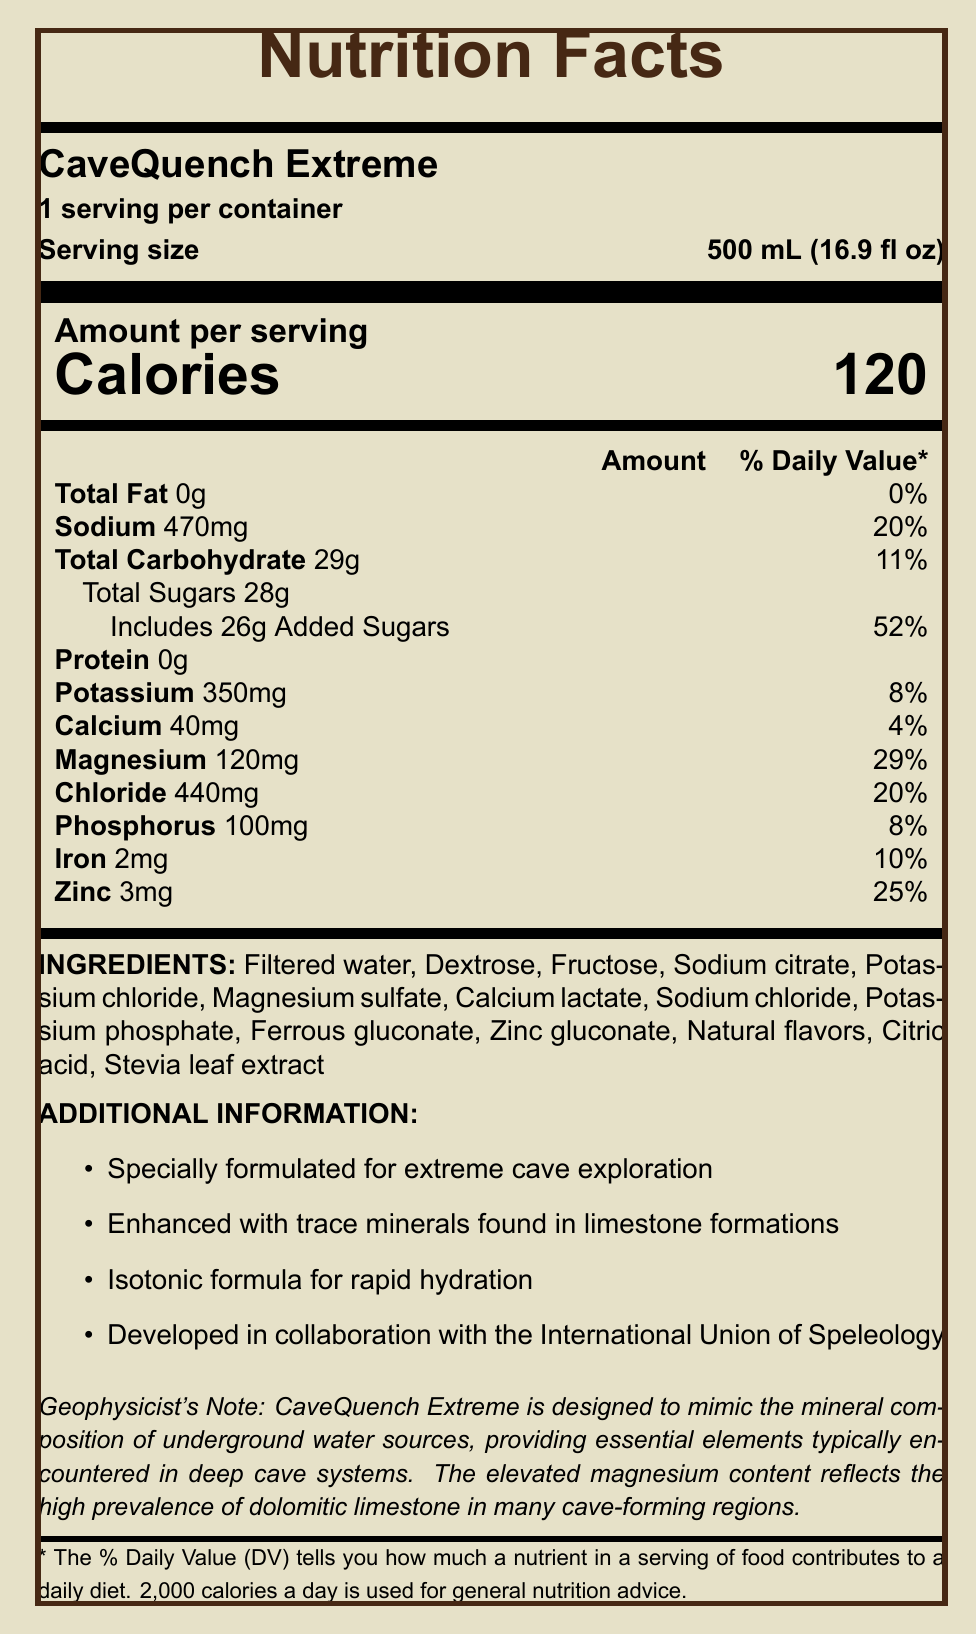what is the product name? The product name is clearly listed at the top of the document.
Answer: CaveQuench Extreme what is the serving size? The serving size is specified right below the product name.
Answer: 500 mL (16.9 fl oz) how many calories are in one serving? The document states "Calories 120" under the "Amount per serving" section.
Answer: 120 calories what is the percentage of daily value for sodium in one serving? The document lists sodium content as 470mg, which is 20% of the daily value.
Answer: 20% how much magnesium is in one serving? The document lists the magnesium content as 120mg.
Answer: 120mg based on the document, what kind of contexts is CaveQuench Extreme specially formulated for? The "Additional Information" section specifies that the beverage is "specially formulated for extreme cave exploration."
Answer: extreme cave exploration what ingredients are used in CaveQuench Extreme? The ingredients are listed under the "INGREDIENTS" section in the document.
Answer: Filtered water, Dextrose, Fructose, Sodium citrate, Potassium chloride, Magnesium sulfate, Calcium lactate, Sodium chloride, Potassium phosphate, Ferrous gluconate, Zinc gluconate, Natural flavors, Citric acid, Stevia leaf extract how many grams of total carbohydrates are in one serving? The document lists the total carbohydrate content as 29g under the nutritional information.
Answer: 29g what organization collaborated in the development of CaveQuench Extreme? The "Additional Information" section states that the product was "developed in collaboration with the International Union of Speleology."
Answer: International Union of Speleology which of the following is NOT listed as a trace mineral in CaveQuench Extreme? A. Magnesium B. Iron C. Selenium D. Zinc Selenium is not listed in the nutritional information, while Magnesium, Iron, and Zinc are.
Answer: C. Selenium what is the percentage of daily value for added sugars in one serving? A. 26% B. 52% C. 11% D. 29% The document lists "Includes 26g Added Sugars" and mentions this is 52% of the daily value.
Answer: B. 52% is this beverage suitable for someone on a low-sodium diet? The document lists sodium content as 470mg, which is 20% of the daily value, making it unsuitable for a low-sodium diet.
Answer: No what does the geophysicist's note say about the magnesium content in CaveQuench Extreme? The geophysicist's note states that the elevated magnesium content is due to the high prevalence of dolomitic limestone in cave-forming regions.
Answer: The elevated magnesium content reflects the high prevalence of dolomitic limestone in many cave-forming regions. could you summarize the main focus of the document? The summary explains that the document details the nutritional information and unique formulation aspects of CaveQuench Extreme, emphasizing its purpose for cave explorers and specific mineral content benefits.
Answer: The document provides detailed nutritional information about the high-mineral content beverage CaveQuench Extreme, including its ingredients, nutritional values, and special formulation for extreme cave exploration. It highlights the beverage's isotonic formula, enhanced trace minerals, and collaboration with the International Union of Speleology. what is the cost of one container of CaveQuench Extreme? The document does not provide any information regarding the cost of the product.
Answer: Cannot be determined 